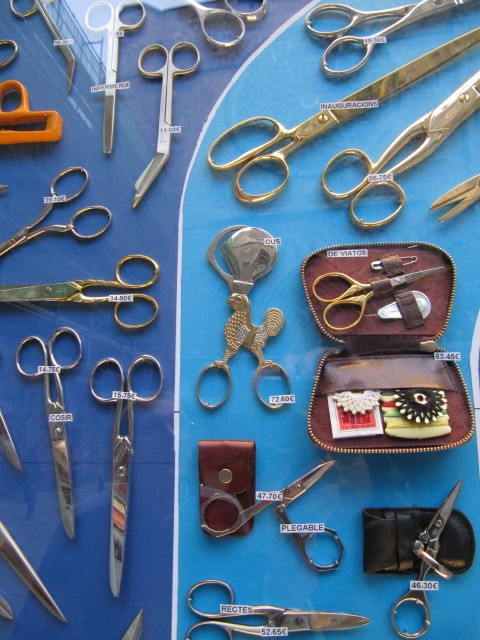Describe the objects in this image and their specific colors. I can see scissors in blue, gray, tan, and lightblue tones, scissors in blue, gray, tan, darkgray, and white tones, scissors in blue, gray, and navy tones, scissors in blue, gray, darkgray, and tan tones, and scissors in blue, gray, teal, and darkblue tones in this image. 